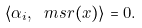<formula> <loc_0><loc_0><loc_500><loc_500>\langle \alpha _ { i } , \ m s r ( x ) \rangle = 0 .</formula> 